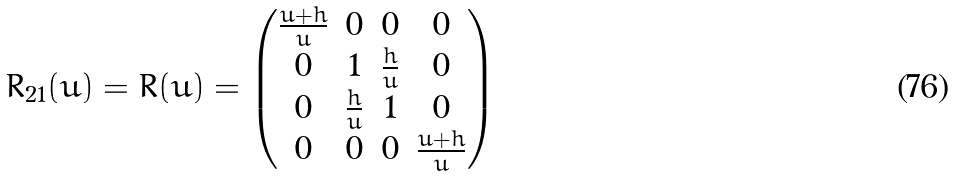Convert formula to latex. <formula><loc_0><loc_0><loc_500><loc_500>\bar { R } _ { 2 1 } ( u ) = \bar { R } ( u ) = \begin{pmatrix} \frac { u + h } { u } & 0 & 0 & 0 \\ 0 & 1 & \frac { h } { u } & 0 \\ 0 & \frac { h } { u } & 1 & 0 \\ 0 & 0 & 0 & \frac { u + h } { u } \end{pmatrix}</formula> 